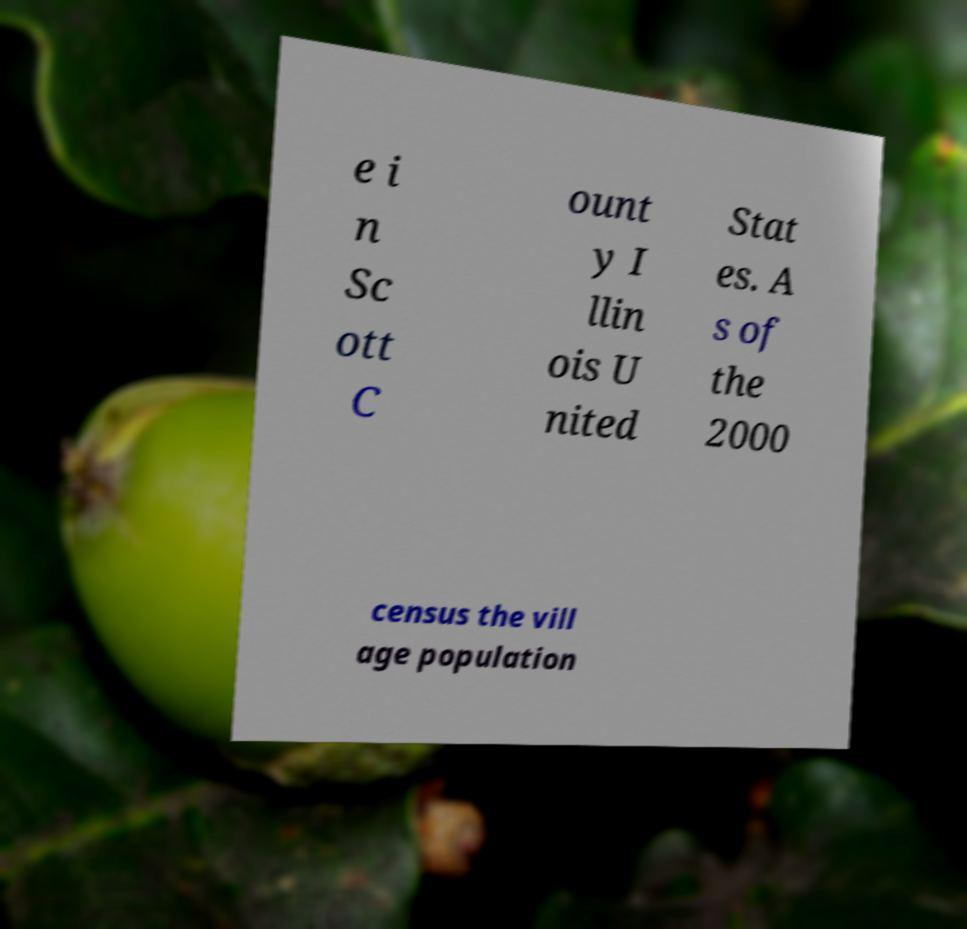There's text embedded in this image that I need extracted. Can you transcribe it verbatim? e i n Sc ott C ount y I llin ois U nited Stat es. A s of the 2000 census the vill age population 